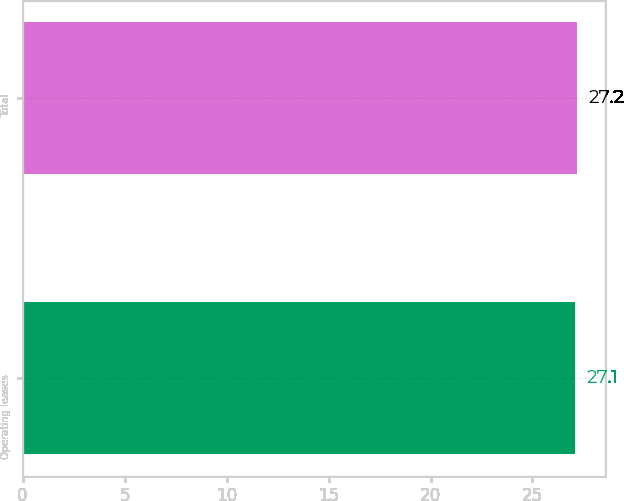Convert chart to OTSL. <chart><loc_0><loc_0><loc_500><loc_500><bar_chart><fcel>Operating leases<fcel>Total<nl><fcel>27.1<fcel>27.2<nl></chart> 